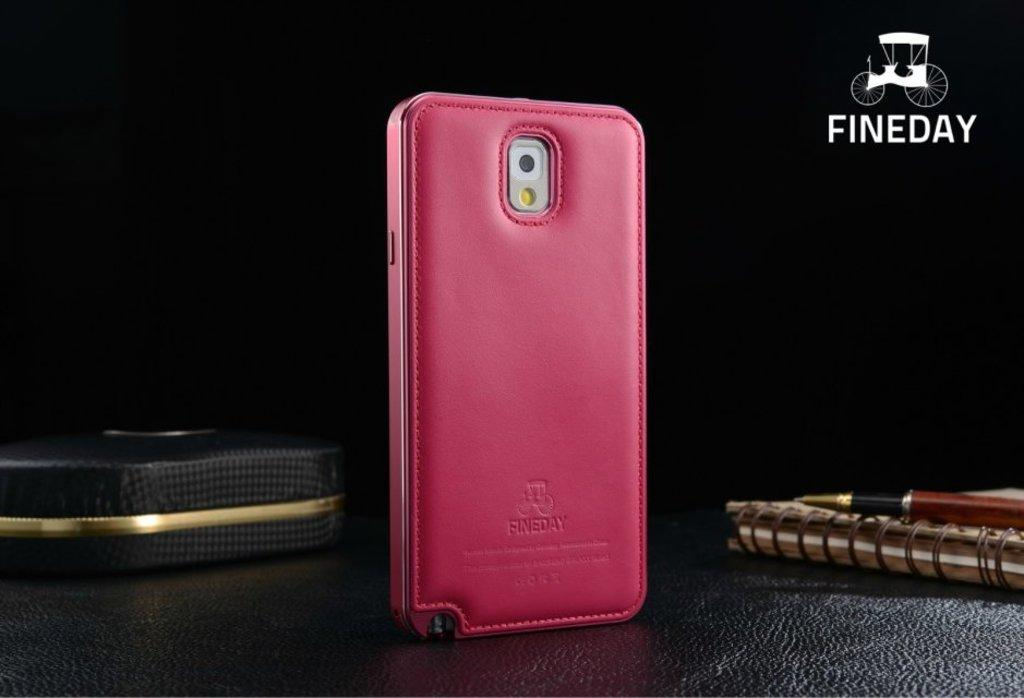What is the color of the surface in the image? The image has a black surface. What objects can be seen on the black surface? There is a book, a pen, a mobile case, and a box on the black surface. Can you describe the watermark in the image? There is a watermark in the right top corner of the image. What type of weather can be seen in the image? There is no weather depicted in the image, as it is a still image of objects on a black surface. What authority figure is present in the image? There is no authority figure present in the image; it features a book, a pen, a mobile case, and a box on a black surface. 